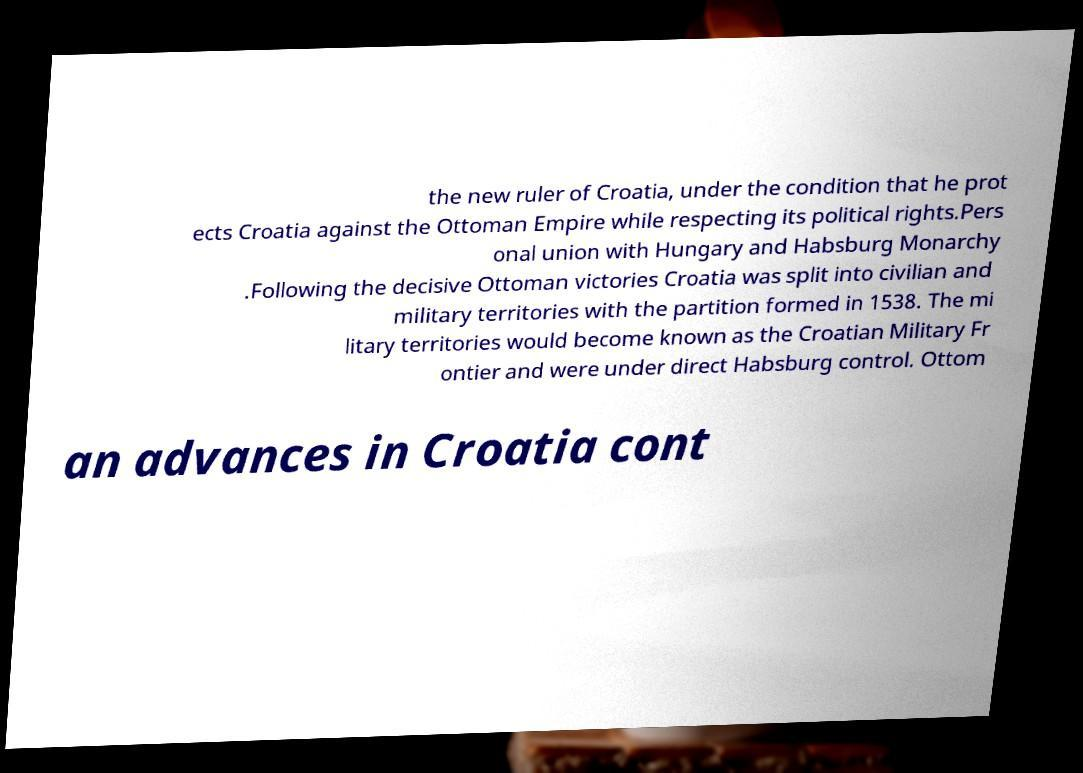I need the written content from this picture converted into text. Can you do that? the new ruler of Croatia, under the condition that he prot ects Croatia against the Ottoman Empire while respecting its political rights.Pers onal union with Hungary and Habsburg Monarchy .Following the decisive Ottoman victories Croatia was split into civilian and military territories with the partition formed in 1538. The mi litary territories would become known as the Croatian Military Fr ontier and were under direct Habsburg control. Ottom an advances in Croatia cont 